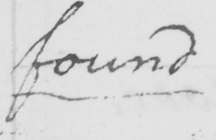What is written in this line of handwriting? found 